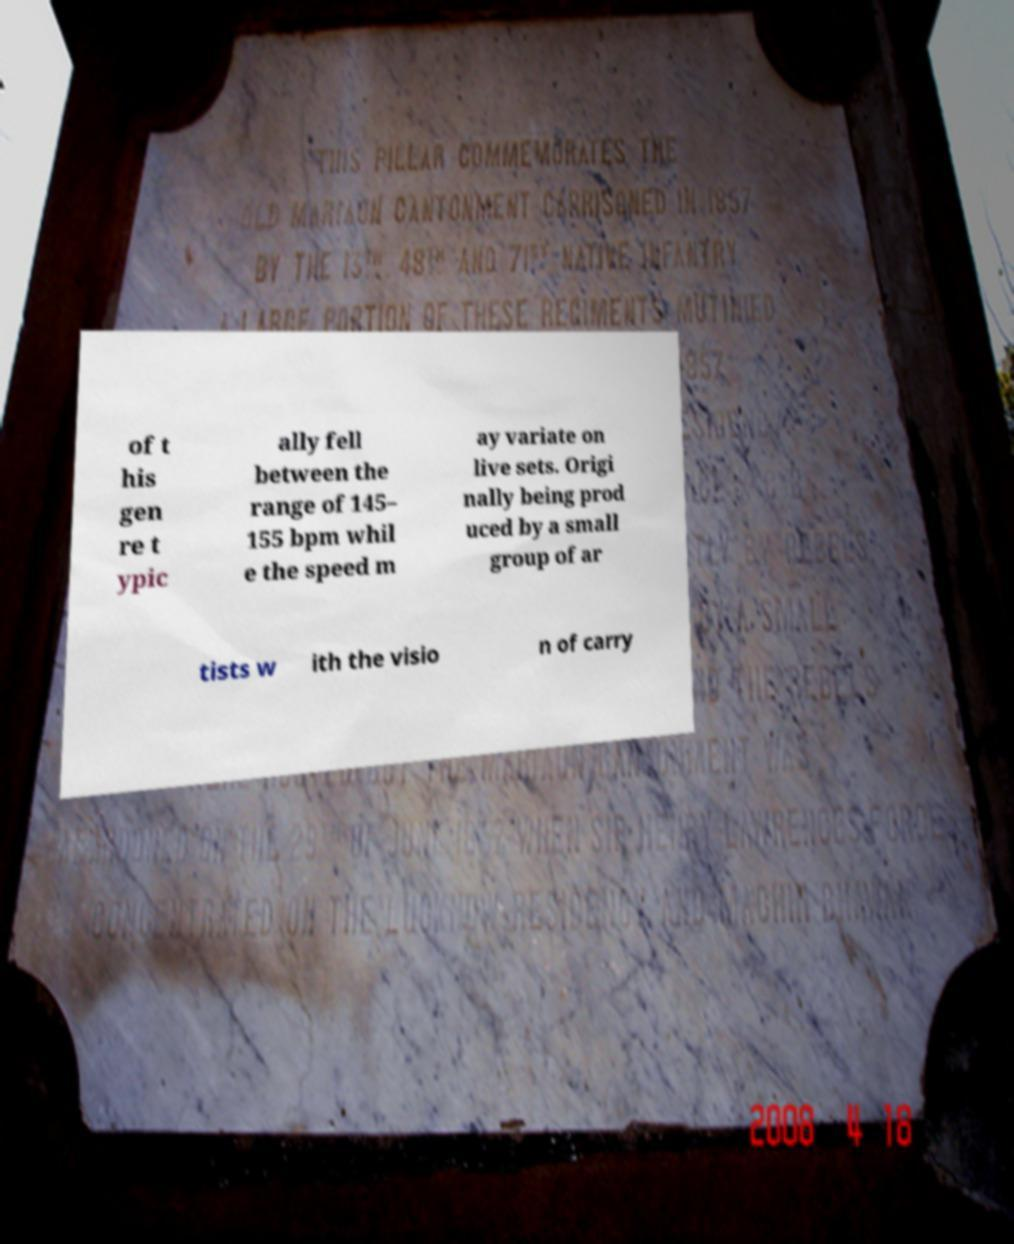Please identify and transcribe the text found in this image. of t his gen re t ypic ally fell between the range of 145– 155 bpm whil e the speed m ay variate on live sets. Origi nally being prod uced by a small group of ar tists w ith the visio n of carry 